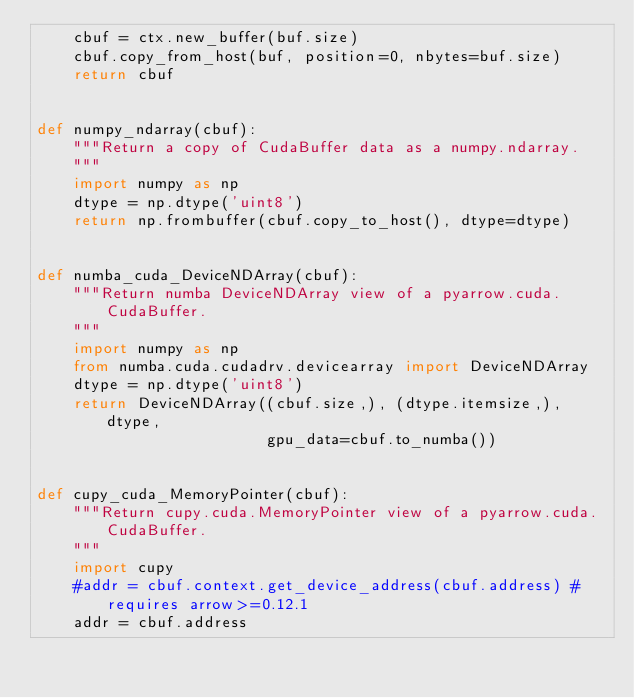Convert code to text. <code><loc_0><loc_0><loc_500><loc_500><_Python_>    cbuf = ctx.new_buffer(buf.size)
    cbuf.copy_from_host(buf, position=0, nbytes=buf.size)
    return cbuf


def numpy_ndarray(cbuf):
    """Return a copy of CudaBuffer data as a numpy.ndarray.
    """
    import numpy as np
    dtype = np.dtype('uint8')
    return np.frombuffer(cbuf.copy_to_host(), dtype=dtype)


def numba_cuda_DeviceNDArray(cbuf):
    """Return numba DeviceNDArray view of a pyarrow.cuda.CudaBuffer.
    """
    import numpy as np
    from numba.cuda.cudadrv.devicearray import DeviceNDArray
    dtype = np.dtype('uint8')
    return DeviceNDArray((cbuf.size,), (dtype.itemsize,), dtype,
                         gpu_data=cbuf.to_numba())


def cupy_cuda_MemoryPointer(cbuf):
    """Return cupy.cuda.MemoryPointer view of a pyarrow.cuda.CudaBuffer.
    """
    import cupy
    #addr = cbuf.context.get_device_address(cbuf.address) # requires arrow>=0.12.1
    addr = cbuf.address</code> 